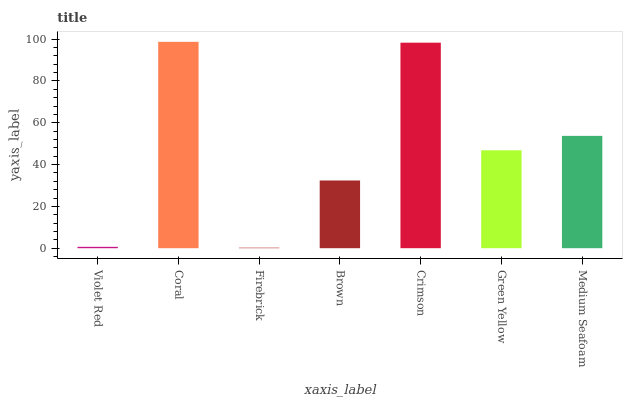Is Firebrick the minimum?
Answer yes or no. Yes. Is Coral the maximum?
Answer yes or no. Yes. Is Coral the minimum?
Answer yes or no. No. Is Firebrick the maximum?
Answer yes or no. No. Is Coral greater than Firebrick?
Answer yes or no. Yes. Is Firebrick less than Coral?
Answer yes or no. Yes. Is Firebrick greater than Coral?
Answer yes or no. No. Is Coral less than Firebrick?
Answer yes or no. No. Is Green Yellow the high median?
Answer yes or no. Yes. Is Green Yellow the low median?
Answer yes or no. Yes. Is Crimson the high median?
Answer yes or no. No. Is Crimson the low median?
Answer yes or no. No. 